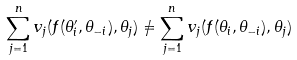<formula> <loc_0><loc_0><loc_500><loc_500>\sum _ { j = 1 } ^ { n } v _ { j } ( f ( \theta ^ { \prime } _ { i } , \theta _ { - i } ) , \theta _ { j } ) \neq \sum _ { j = 1 } ^ { n } v _ { j } ( f ( \theta _ { i } , \theta _ { - i } ) , \theta _ { j } )</formula> 